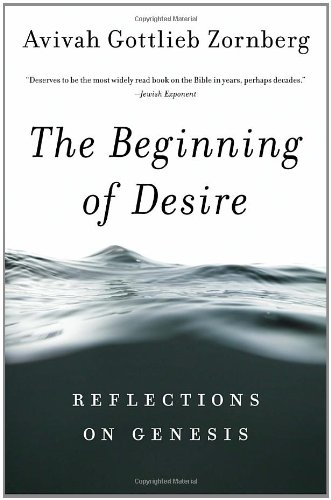Who is the author of this book? The author of the book shown is Avivah Gottlieb Zornberg, an acclaimed scholar known for her deep reflections on biblical texts. 